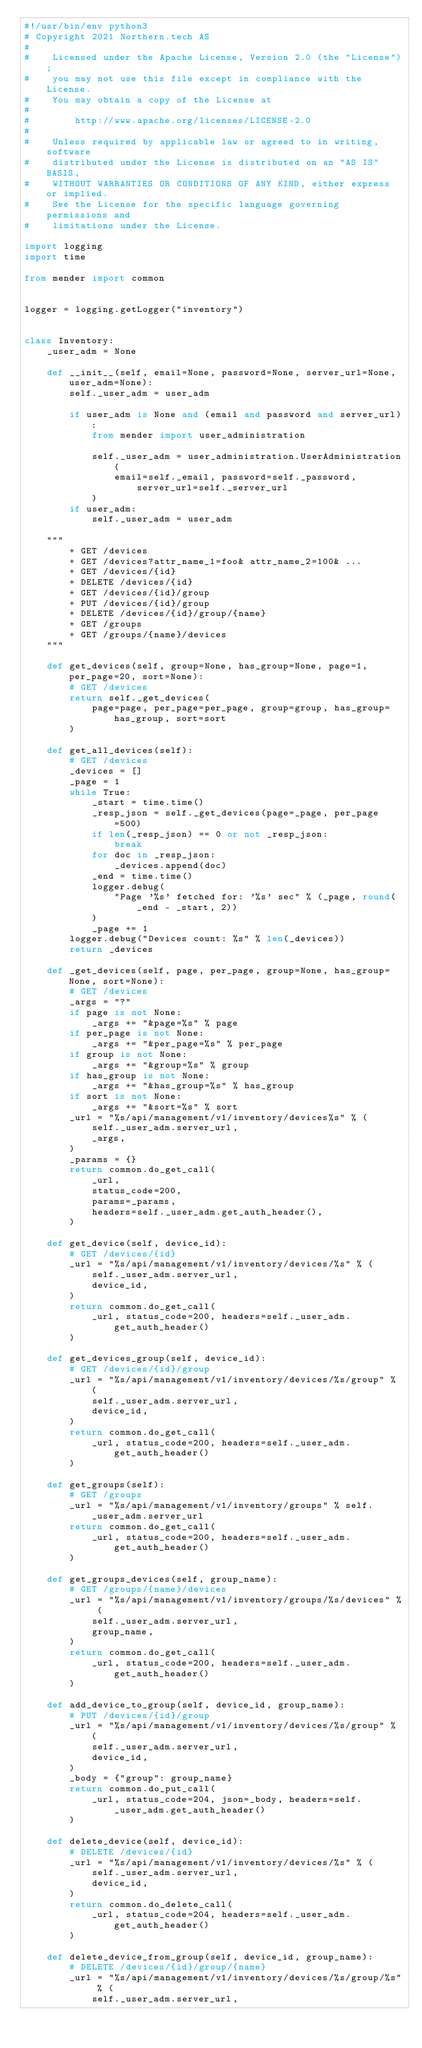<code> <loc_0><loc_0><loc_500><loc_500><_Python_>#!/usr/bin/env python3
# Copyright 2021 Northern.tech AS
#
#    Licensed under the Apache License, Version 2.0 (the "License");
#    you may not use this file except in compliance with the License.
#    You may obtain a copy of the License at
#
#        http://www.apache.org/licenses/LICENSE-2.0
#
#    Unless required by applicable law or agreed to in writing, software
#    distributed under the License is distributed on an "AS IS" BASIS,
#    WITHOUT WARRANTIES OR CONDITIONS OF ANY KIND, either express or implied.
#    See the License for the specific language governing permissions and
#    limitations under the License.

import logging
import time

from mender import common


logger = logging.getLogger("inventory")


class Inventory:
    _user_adm = None

    def __init__(self, email=None, password=None, server_url=None, user_adm=None):
        self._user_adm = user_adm

        if user_adm is None and (email and password and server_url):
            from mender import user_administration

            self._user_adm = user_administration.UserAdministration(
                email=self._email, password=self._password, server_url=self._server_url
            )
        if user_adm:
            self._user_adm = user_adm

    """
        + GET /devices
        + GET /devices?attr_name_1=foo& attr_name_2=100& ...
        + GET /devices/{id}
        + DELETE /devices/{id}
        + GET /devices/{id}/group
        + PUT /devices/{id}/group
        + DELETE /devices/{id}/group/{name}
        + GET /groups
        + GET /groups/{name}/devices
    """

    def get_devices(self, group=None, has_group=None, page=1, per_page=20, sort=None):
        # GET /devices
        return self._get_devices(
            page=page, per_page=per_page, group=group, has_group=has_group, sort=sort
        )

    def get_all_devices(self):
        # GET /devices
        _devices = []
        _page = 1
        while True:
            _start = time.time()
            _resp_json = self._get_devices(page=_page, per_page=500)
            if len(_resp_json) == 0 or not _resp_json:
                break
            for doc in _resp_json:
                _devices.append(doc)
            _end = time.time()
            logger.debug(
                "Page '%s' fetched for: '%s' sec" % (_page, round(_end - _start, 2))
            )
            _page += 1
        logger.debug("Devices count: %s" % len(_devices))
        return _devices

    def _get_devices(self, page, per_page, group=None, has_group=None, sort=None):
        # GET /devices
        _args = "?"
        if page is not None:
            _args += "&page=%s" % page
        if per_page is not None:
            _args += "&per_page=%s" % per_page
        if group is not None:
            _args += "&group=%s" % group
        if has_group is not None:
            _args += "&has_group=%s" % has_group
        if sort is not None:
            _args += "&sort=%s" % sort
        _url = "%s/api/management/v1/inventory/devices%s" % (
            self._user_adm.server_url,
            _args,
        )
        _params = {}
        return common.do_get_call(
            _url,
            status_code=200,
            params=_params,
            headers=self._user_adm.get_auth_header(),
        )

    def get_device(self, device_id):
        # GET /devices/{id}
        _url = "%s/api/management/v1/inventory/devices/%s" % (
            self._user_adm.server_url,
            device_id,
        )
        return common.do_get_call(
            _url, status_code=200, headers=self._user_adm.get_auth_header()
        )

    def get_devices_group(self, device_id):
        # GET /devices/{id}/group
        _url = "%s/api/management/v1/inventory/devices/%s/group" % (
            self._user_adm.server_url,
            device_id,
        )
        return common.do_get_call(
            _url, status_code=200, headers=self._user_adm.get_auth_header()
        )

    def get_groups(self):
        # GET /groups
        _url = "%s/api/management/v1/inventory/groups" % self._user_adm.server_url
        return common.do_get_call(
            _url, status_code=200, headers=self._user_adm.get_auth_header()
        )

    def get_groups_devices(self, group_name):
        # GET /groups/{name}/devices
        _url = "%s/api/management/v1/inventory/groups/%s/devices" % (
            self._user_adm.server_url,
            group_name,
        )
        return common.do_get_call(
            _url, status_code=200, headers=self._user_adm.get_auth_header()
        )

    def add_device_to_group(self, device_id, group_name):
        # PUT /devices/{id}/group
        _url = "%s/api/management/v1/inventory/devices/%s/group" % (
            self._user_adm.server_url,
            device_id,
        )
        _body = {"group": group_name}
        return common.do_put_call(
            _url, status_code=204, json=_body, headers=self._user_adm.get_auth_header()
        )

    def delete_device(self, device_id):
        # DELETE /devices/{id}
        _url = "%s/api/management/v1/inventory/devices/%s" % (
            self._user_adm.server_url,
            device_id,
        )
        return common.do_delete_call(
            _url, status_code=204, headers=self._user_adm.get_auth_header()
        )

    def delete_device_from_group(self, device_id, group_name):
        # DELETE /devices/{id}/group/{name}
        _url = "%s/api/management/v1/inventory/devices/%s/group/%s" % (
            self._user_adm.server_url,</code> 